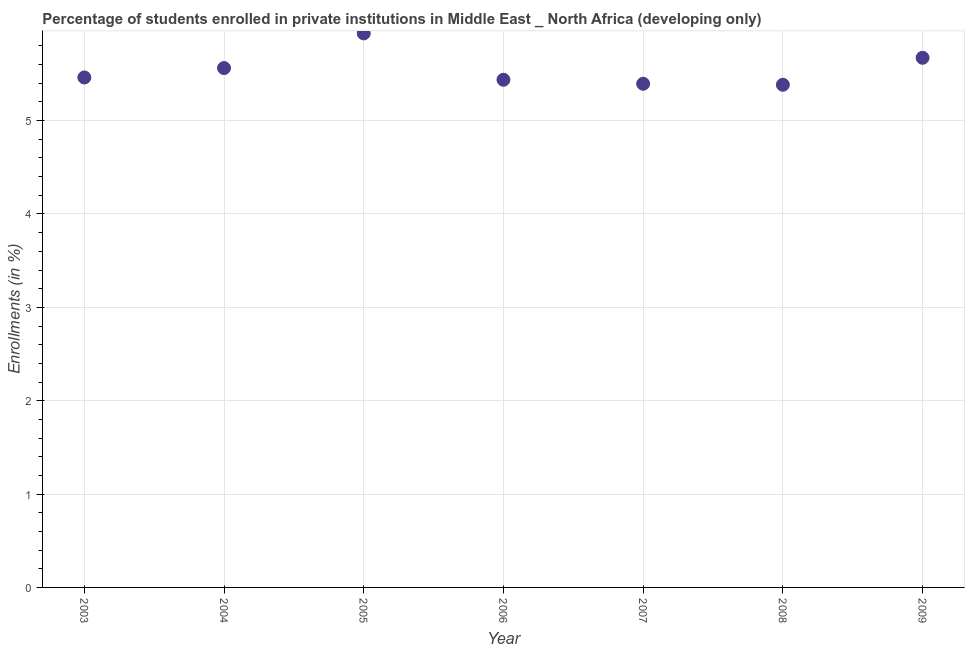What is the enrollments in private institutions in 2003?
Ensure brevity in your answer.  5.46. Across all years, what is the maximum enrollments in private institutions?
Offer a terse response. 5.93. Across all years, what is the minimum enrollments in private institutions?
Your response must be concise. 5.38. In which year was the enrollments in private institutions minimum?
Keep it short and to the point. 2008. What is the sum of the enrollments in private institutions?
Keep it short and to the point. 38.85. What is the difference between the enrollments in private institutions in 2007 and 2008?
Offer a terse response. 0.01. What is the average enrollments in private institutions per year?
Your answer should be very brief. 5.55. What is the median enrollments in private institutions?
Offer a very short reply. 5.46. In how many years, is the enrollments in private institutions greater than 1 %?
Your answer should be very brief. 7. What is the ratio of the enrollments in private institutions in 2003 to that in 2006?
Keep it short and to the point. 1. What is the difference between the highest and the second highest enrollments in private institutions?
Keep it short and to the point. 0.26. What is the difference between the highest and the lowest enrollments in private institutions?
Your answer should be very brief. 0.55. In how many years, is the enrollments in private institutions greater than the average enrollments in private institutions taken over all years?
Keep it short and to the point. 3. How many dotlines are there?
Offer a very short reply. 1. How many years are there in the graph?
Give a very brief answer. 7. What is the difference between two consecutive major ticks on the Y-axis?
Offer a terse response. 1. Does the graph contain any zero values?
Ensure brevity in your answer.  No. What is the title of the graph?
Provide a short and direct response. Percentage of students enrolled in private institutions in Middle East _ North Africa (developing only). What is the label or title of the Y-axis?
Provide a succinct answer. Enrollments (in %). What is the Enrollments (in %) in 2003?
Offer a terse response. 5.46. What is the Enrollments (in %) in 2004?
Your response must be concise. 5.56. What is the Enrollments (in %) in 2005?
Provide a short and direct response. 5.93. What is the Enrollments (in %) in 2006?
Your answer should be compact. 5.44. What is the Enrollments (in %) in 2007?
Offer a terse response. 5.39. What is the Enrollments (in %) in 2008?
Offer a very short reply. 5.38. What is the Enrollments (in %) in 2009?
Your answer should be very brief. 5.67. What is the difference between the Enrollments (in %) in 2003 and 2004?
Your answer should be compact. -0.1. What is the difference between the Enrollments (in %) in 2003 and 2005?
Make the answer very short. -0.47. What is the difference between the Enrollments (in %) in 2003 and 2006?
Offer a terse response. 0.02. What is the difference between the Enrollments (in %) in 2003 and 2007?
Provide a succinct answer. 0.07. What is the difference between the Enrollments (in %) in 2003 and 2008?
Give a very brief answer. 0.08. What is the difference between the Enrollments (in %) in 2003 and 2009?
Offer a terse response. -0.21. What is the difference between the Enrollments (in %) in 2004 and 2005?
Give a very brief answer. -0.37. What is the difference between the Enrollments (in %) in 2004 and 2006?
Ensure brevity in your answer.  0.13. What is the difference between the Enrollments (in %) in 2004 and 2007?
Offer a terse response. 0.17. What is the difference between the Enrollments (in %) in 2004 and 2008?
Give a very brief answer. 0.18. What is the difference between the Enrollments (in %) in 2004 and 2009?
Provide a succinct answer. -0.11. What is the difference between the Enrollments (in %) in 2005 and 2006?
Your response must be concise. 0.5. What is the difference between the Enrollments (in %) in 2005 and 2007?
Offer a very short reply. 0.54. What is the difference between the Enrollments (in %) in 2005 and 2008?
Your response must be concise. 0.55. What is the difference between the Enrollments (in %) in 2005 and 2009?
Ensure brevity in your answer.  0.26. What is the difference between the Enrollments (in %) in 2006 and 2007?
Provide a short and direct response. 0.04. What is the difference between the Enrollments (in %) in 2006 and 2008?
Your answer should be very brief. 0.05. What is the difference between the Enrollments (in %) in 2006 and 2009?
Your answer should be compact. -0.24. What is the difference between the Enrollments (in %) in 2007 and 2008?
Your response must be concise. 0.01. What is the difference between the Enrollments (in %) in 2007 and 2009?
Offer a terse response. -0.28. What is the difference between the Enrollments (in %) in 2008 and 2009?
Your response must be concise. -0.29. What is the ratio of the Enrollments (in %) in 2003 to that in 2007?
Provide a short and direct response. 1.01. What is the ratio of the Enrollments (in %) in 2004 to that in 2005?
Offer a very short reply. 0.94. What is the ratio of the Enrollments (in %) in 2004 to that in 2007?
Ensure brevity in your answer.  1.03. What is the ratio of the Enrollments (in %) in 2004 to that in 2008?
Give a very brief answer. 1.03. What is the ratio of the Enrollments (in %) in 2005 to that in 2006?
Keep it short and to the point. 1.09. What is the ratio of the Enrollments (in %) in 2005 to that in 2008?
Provide a succinct answer. 1.1. What is the ratio of the Enrollments (in %) in 2005 to that in 2009?
Your response must be concise. 1.05. What is the ratio of the Enrollments (in %) in 2006 to that in 2007?
Give a very brief answer. 1.01. What is the ratio of the Enrollments (in %) in 2006 to that in 2009?
Your answer should be compact. 0.96. What is the ratio of the Enrollments (in %) in 2007 to that in 2009?
Keep it short and to the point. 0.95. What is the ratio of the Enrollments (in %) in 2008 to that in 2009?
Make the answer very short. 0.95. 